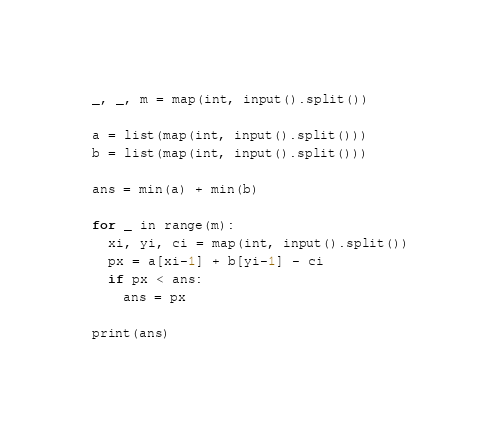<code> <loc_0><loc_0><loc_500><loc_500><_Python_>_, _, m = map(int, input().split()) 

a = list(map(int, input().split()))
b = list(map(int, input().split()))

ans = min(a) + min(b)

for _ in range(m):
  xi, yi, ci = map(int, input().split())
  px = a[xi-1] + b[yi-1] - ci
  if px < ans:
    ans = px

print(ans)</code> 